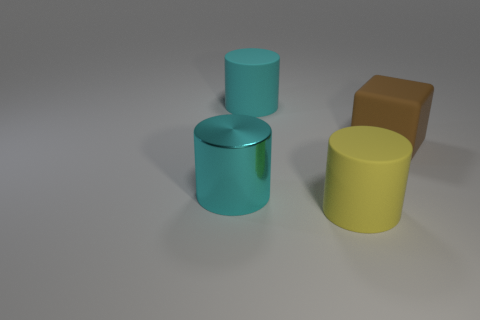Are the big brown object and the big yellow thing made of the same material?
Your answer should be compact. Yes. Are there the same number of big rubber objects behind the large metal cylinder and brown rubber things?
Provide a short and direct response. No. How many cyan cylinders have the same material as the cube?
Offer a very short reply. 1. Is the number of brown shiny cylinders less than the number of brown matte things?
Your answer should be compact. Yes. There is a rubber cylinder on the right side of the large cyan matte cylinder; is its color the same as the metal cylinder?
Offer a very short reply. No. How many cyan things are behind the cylinder that is on the left side of the large cyan thing that is behind the big brown rubber object?
Your response must be concise. 1. How many large brown rubber things are on the right side of the big brown object?
Offer a terse response. 0. What color is the metal object that is the same shape as the cyan rubber object?
Make the answer very short. Cyan. What is the material of the big object that is both on the right side of the large cyan rubber cylinder and behind the large cyan metallic cylinder?
Make the answer very short. Rubber. Does the cyan thing that is in front of the brown rubber thing have the same size as the large cyan matte cylinder?
Offer a terse response. Yes. 